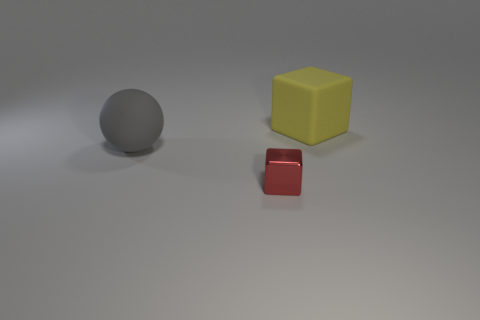What can you infer about the surface on which the objects are placed? The surface seems to be a smooth, matte-finished material with a slight gradient of light that darkens toward the edges of the image. There's no visible grain or texture, which would imply that the material could be synthetic or processed, commonly found in studio environments for photography or rendering purposes. How would you interpret the spatial composition of the objects in the image? The spatial composition seems deliberate, with objects arranged at different distances to create a sense of depth. The placement also appears to form a left-to-right diagonal line that may suggest movement or guide the viewer's eye across the image, providing visual interest and balance. 